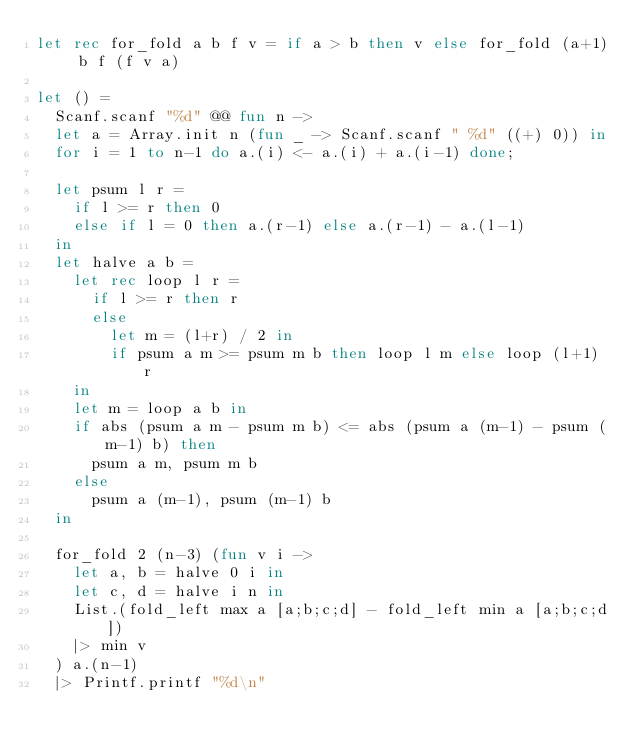Convert code to text. <code><loc_0><loc_0><loc_500><loc_500><_OCaml_>let rec for_fold a b f v = if a > b then v else for_fold (a+1) b f (f v a)

let () =
  Scanf.scanf "%d" @@ fun n ->
  let a = Array.init n (fun _ -> Scanf.scanf " %d" ((+) 0)) in
  for i = 1 to n-1 do a.(i) <- a.(i) + a.(i-1) done;

  let psum l r =
    if l >= r then 0
    else if l = 0 then a.(r-1) else a.(r-1) - a.(l-1)
  in
  let halve a b =
    let rec loop l r =
      if l >= r then r
      else
        let m = (l+r) / 2 in
        if psum a m >= psum m b then loop l m else loop (l+1) r
    in
    let m = loop a b in
    if abs (psum a m - psum m b) <= abs (psum a (m-1) - psum (m-1) b) then
      psum a m, psum m b
    else
      psum a (m-1), psum (m-1) b
  in

  for_fold 2 (n-3) (fun v i ->
    let a, b = halve 0 i in
    let c, d = halve i n in
    List.(fold_left max a [a;b;c;d] - fold_left min a [a;b;c;d])
    |> min v
  ) a.(n-1) 
  |> Printf.printf "%d\n"
</code> 